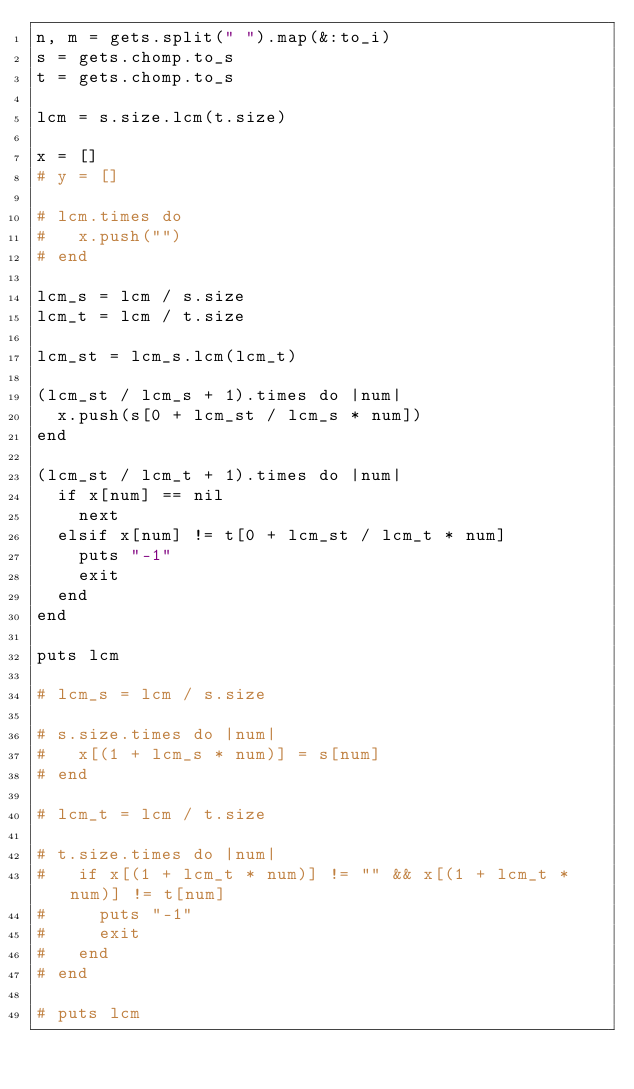Convert code to text. <code><loc_0><loc_0><loc_500><loc_500><_Ruby_>n, m = gets.split(" ").map(&:to_i)
s = gets.chomp.to_s
t = gets.chomp.to_s

lcm = s.size.lcm(t.size)

x = []
# y = []

# lcm.times do
#   x.push("")
# end

lcm_s = lcm / s.size
lcm_t = lcm / t.size

lcm_st = lcm_s.lcm(lcm_t)

(lcm_st / lcm_s + 1).times do |num|
  x.push(s[0 + lcm_st / lcm_s * num])
end

(lcm_st / lcm_t + 1).times do |num|
  if x[num] == nil
    next
  elsif x[num] != t[0 + lcm_st / lcm_t * num]
    puts "-1"
    exit
  end
end

puts lcm

# lcm_s = lcm / s.size

# s.size.times do |num|
#   x[(1 + lcm_s * num)] = s[num]
# end

# lcm_t = lcm / t.size

# t.size.times do |num|
#   if x[(1 + lcm_t * num)] != "" && x[(1 + lcm_t * num)] != t[num]
#     puts "-1"
#     exit
#   end
# end

# puts lcm</code> 